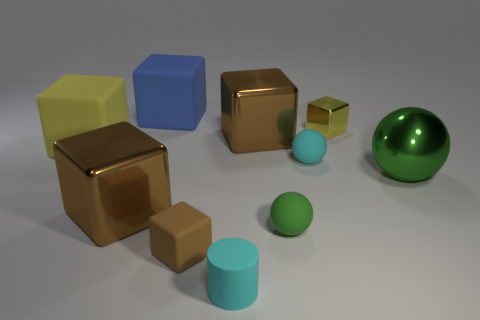Are there any other things that are the same size as the green rubber sphere?
Keep it short and to the point. Yes. There is another green object that is the same shape as the large green shiny object; what is its material?
Ensure brevity in your answer.  Rubber. Is there a matte cylinder in front of the large brown thing that is left of the big shiny cube that is to the right of the big blue cube?
Make the answer very short. Yes. Does the cyan thing behind the big metal ball have the same shape as the large matte object that is behind the yellow metallic block?
Offer a terse response. No. Is the number of small cubes that are behind the blue cube greater than the number of large green rubber cylinders?
Your answer should be very brief. No. What number of objects are either large purple shiny blocks or yellow shiny things?
Offer a very short reply. 1. The cylinder has what color?
Your answer should be very brief. Cyan. What number of other objects are the same color as the small rubber cube?
Your answer should be compact. 2. Are there any things right of the small brown thing?
Offer a terse response. Yes. There is a cube in front of the big cube in front of the big rubber cube that is in front of the small yellow metal block; what is its color?
Provide a succinct answer. Brown. 